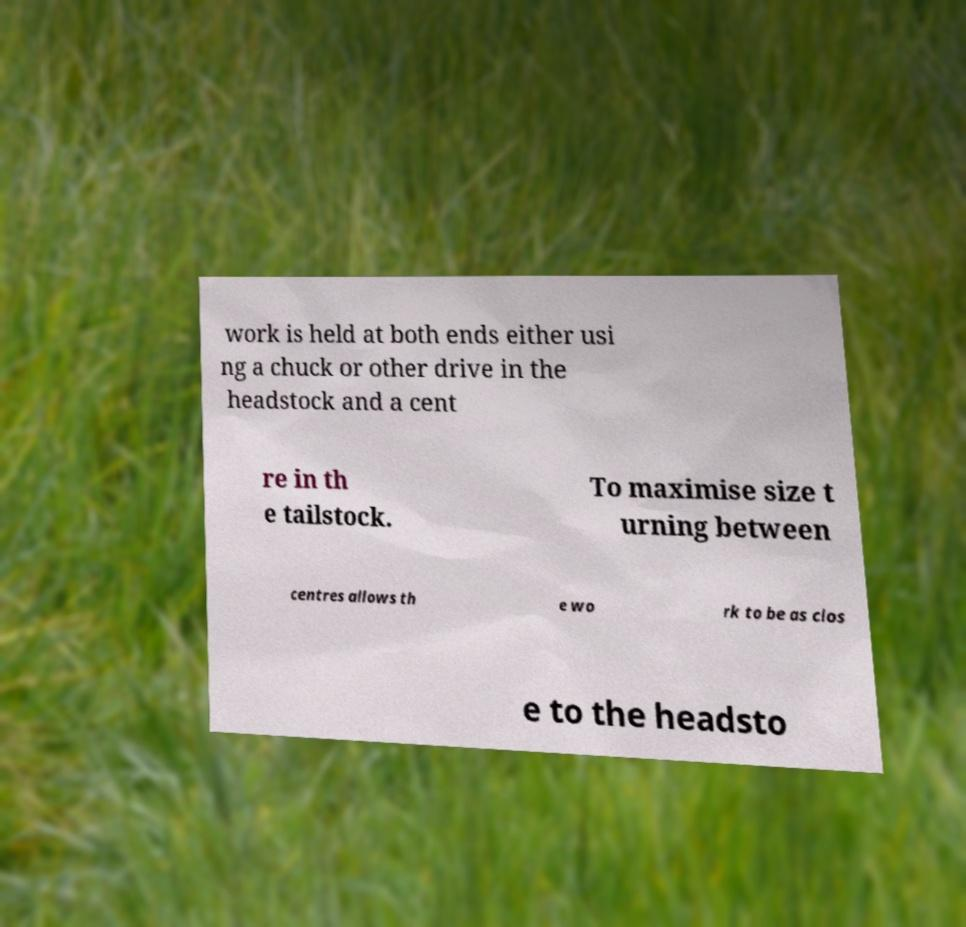There's text embedded in this image that I need extracted. Can you transcribe it verbatim? work is held at both ends either usi ng a chuck or other drive in the headstock and a cent re in th e tailstock. To maximise size t urning between centres allows th e wo rk to be as clos e to the headsto 